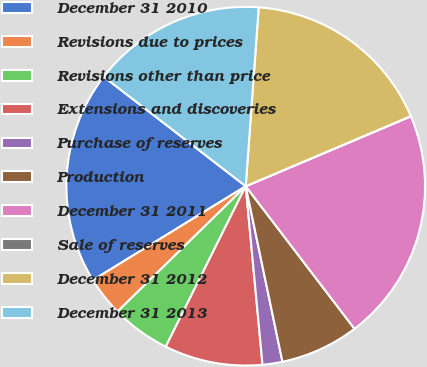Convert chart to OTSL. <chart><loc_0><loc_0><loc_500><loc_500><pie_chart><fcel>December 31 2010<fcel>Revisions due to prices<fcel>Revisions other than price<fcel>Extensions and discoveries<fcel>Purchase of reserves<fcel>Production<fcel>December 31 2011<fcel>Sale of reserves<fcel>December 31 2012<fcel>December 31 2013<nl><fcel>19.23%<fcel>3.55%<fcel>5.32%<fcel>8.85%<fcel>1.79%<fcel>7.09%<fcel>21.0%<fcel>0.02%<fcel>17.46%<fcel>15.7%<nl></chart> 